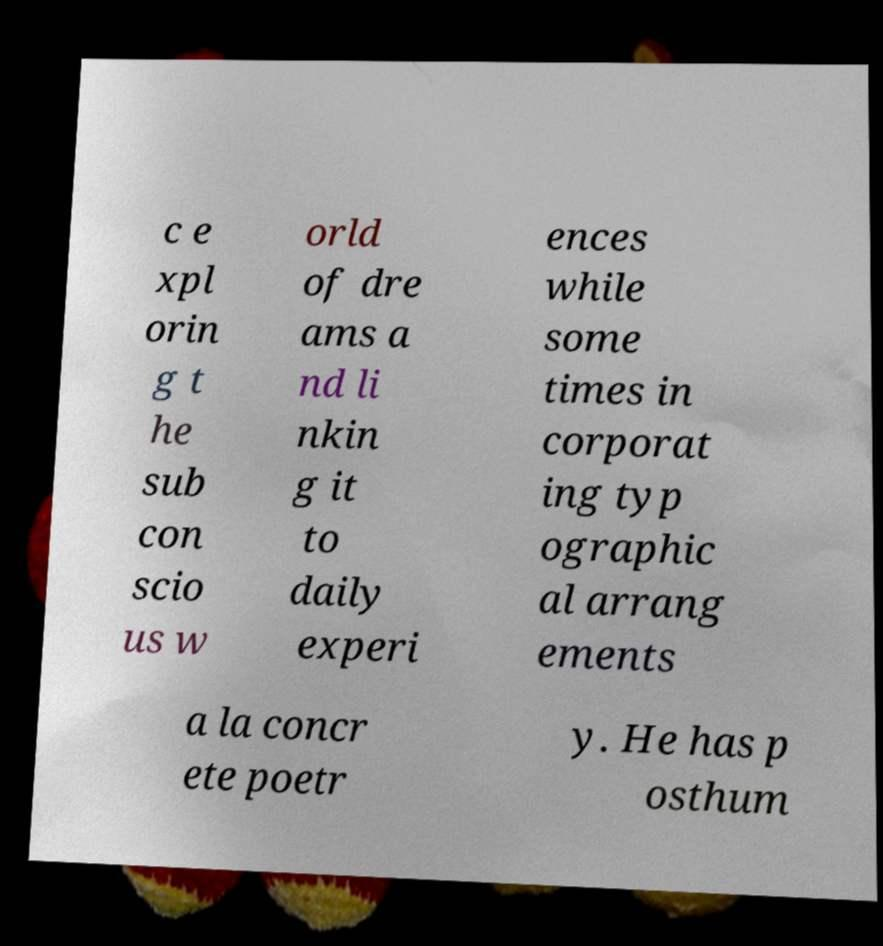What messages or text are displayed in this image? I need them in a readable, typed format. c e xpl orin g t he sub con scio us w orld of dre ams a nd li nkin g it to daily experi ences while some times in corporat ing typ ographic al arrang ements a la concr ete poetr y. He has p osthum 